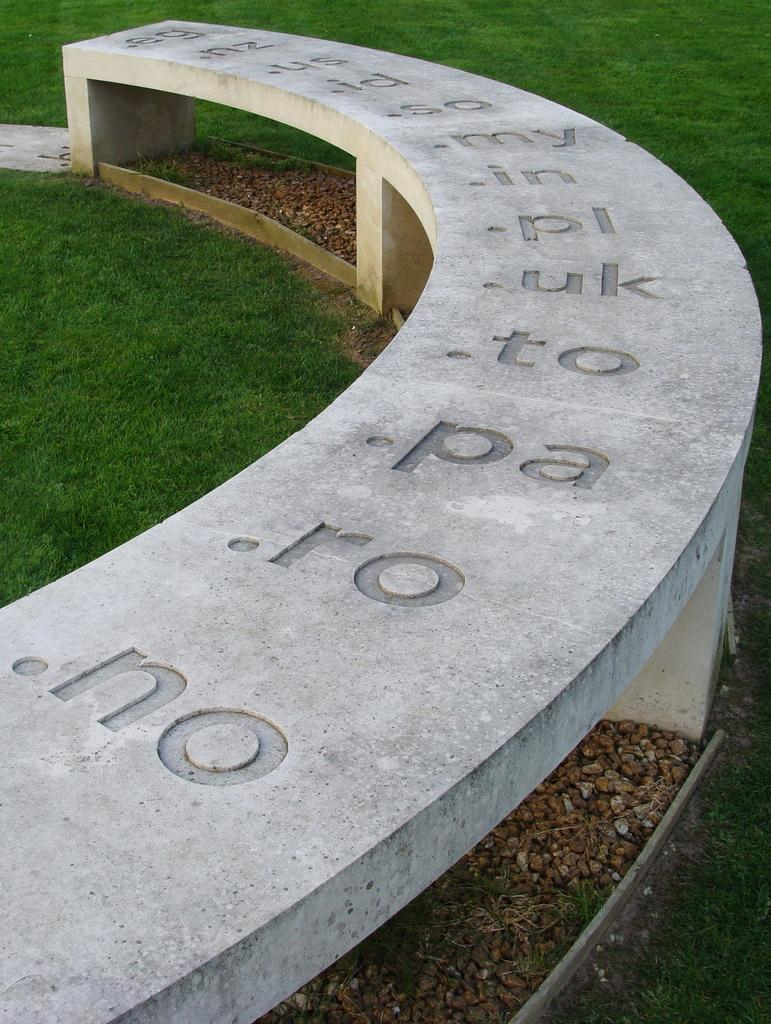What is written on in the image? There are texts written on a concrete platform in the image. What type of surface can be seen on the ground in the image? There are stones and grass on the ground in the image. Where is the faucet located in the image? There is no faucet present in the image. What type of offer is being made in the image? There is no offer being made in the image; it only contains texts on a concrete platform and stones and grass on the ground. 